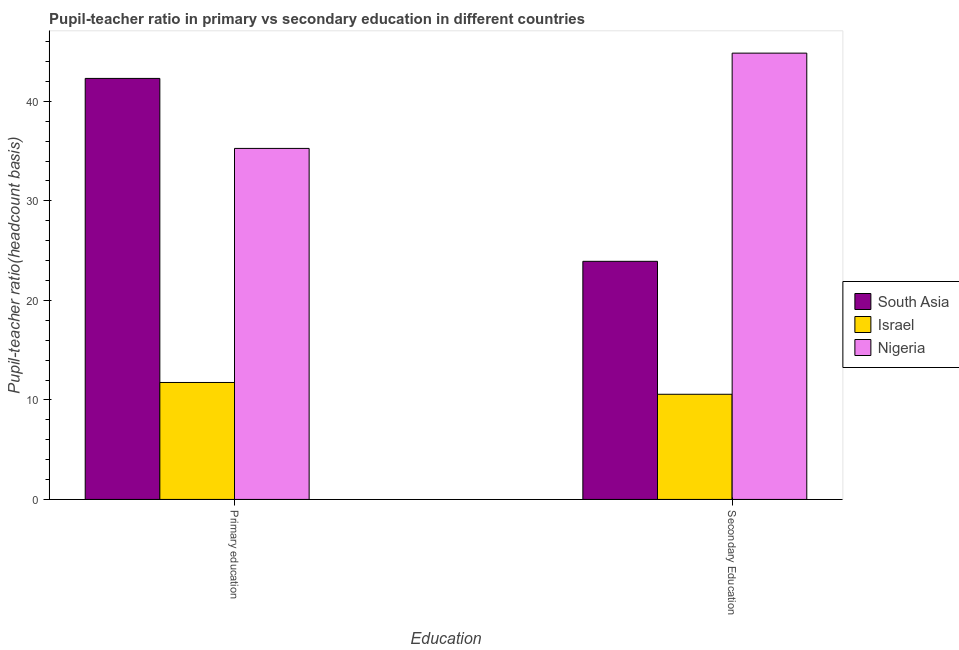How many different coloured bars are there?
Give a very brief answer. 3. Are the number of bars per tick equal to the number of legend labels?
Offer a very short reply. Yes. Are the number of bars on each tick of the X-axis equal?
Provide a succinct answer. Yes. How many bars are there on the 2nd tick from the left?
Your response must be concise. 3. What is the pupil teacher ratio on secondary education in Israel?
Ensure brevity in your answer.  10.57. Across all countries, what is the maximum pupil-teacher ratio in primary education?
Make the answer very short. 42.31. Across all countries, what is the minimum pupil-teacher ratio in primary education?
Your answer should be compact. 11.75. In which country was the pupil-teacher ratio in primary education maximum?
Your response must be concise. South Asia. What is the total pupil-teacher ratio in primary education in the graph?
Ensure brevity in your answer.  89.33. What is the difference between the pupil-teacher ratio in primary education in Israel and that in Nigeria?
Your answer should be compact. -23.52. What is the difference between the pupil teacher ratio on secondary education in Israel and the pupil-teacher ratio in primary education in Nigeria?
Offer a terse response. -24.7. What is the average pupil teacher ratio on secondary education per country?
Your answer should be very brief. 26.45. What is the difference between the pupil teacher ratio on secondary education and pupil-teacher ratio in primary education in South Asia?
Give a very brief answer. -18.38. What is the ratio of the pupil teacher ratio on secondary education in Nigeria to that in Israel?
Make the answer very short. 4.24. What does the 2nd bar from the left in Primary education represents?
Your answer should be very brief. Israel. What does the 3rd bar from the right in Primary education represents?
Offer a terse response. South Asia. How many countries are there in the graph?
Provide a succinct answer. 3. Are the values on the major ticks of Y-axis written in scientific E-notation?
Your answer should be compact. No. Does the graph contain grids?
Keep it short and to the point. No. How are the legend labels stacked?
Your answer should be compact. Vertical. What is the title of the graph?
Your answer should be compact. Pupil-teacher ratio in primary vs secondary education in different countries. Does "Peru" appear as one of the legend labels in the graph?
Make the answer very short. No. What is the label or title of the X-axis?
Ensure brevity in your answer.  Education. What is the label or title of the Y-axis?
Offer a terse response. Pupil-teacher ratio(headcount basis). What is the Pupil-teacher ratio(headcount basis) in South Asia in Primary education?
Your answer should be compact. 42.31. What is the Pupil-teacher ratio(headcount basis) of Israel in Primary education?
Provide a succinct answer. 11.75. What is the Pupil-teacher ratio(headcount basis) in Nigeria in Primary education?
Your response must be concise. 35.27. What is the Pupil-teacher ratio(headcount basis) of South Asia in Secondary Education?
Provide a succinct answer. 23.93. What is the Pupil-teacher ratio(headcount basis) of Israel in Secondary Education?
Ensure brevity in your answer.  10.57. What is the Pupil-teacher ratio(headcount basis) in Nigeria in Secondary Education?
Make the answer very short. 44.85. Across all Education, what is the maximum Pupil-teacher ratio(headcount basis) in South Asia?
Ensure brevity in your answer.  42.31. Across all Education, what is the maximum Pupil-teacher ratio(headcount basis) of Israel?
Your response must be concise. 11.75. Across all Education, what is the maximum Pupil-teacher ratio(headcount basis) in Nigeria?
Keep it short and to the point. 44.85. Across all Education, what is the minimum Pupil-teacher ratio(headcount basis) of South Asia?
Give a very brief answer. 23.93. Across all Education, what is the minimum Pupil-teacher ratio(headcount basis) in Israel?
Your answer should be very brief. 10.57. Across all Education, what is the minimum Pupil-teacher ratio(headcount basis) of Nigeria?
Ensure brevity in your answer.  35.27. What is the total Pupil-teacher ratio(headcount basis) in South Asia in the graph?
Offer a terse response. 66.23. What is the total Pupil-teacher ratio(headcount basis) in Israel in the graph?
Ensure brevity in your answer.  22.32. What is the total Pupil-teacher ratio(headcount basis) in Nigeria in the graph?
Give a very brief answer. 80.12. What is the difference between the Pupil-teacher ratio(headcount basis) in South Asia in Primary education and that in Secondary Education?
Provide a succinct answer. 18.38. What is the difference between the Pupil-teacher ratio(headcount basis) of Israel in Primary education and that in Secondary Education?
Provide a short and direct response. 1.19. What is the difference between the Pupil-teacher ratio(headcount basis) in Nigeria in Primary education and that in Secondary Education?
Offer a very short reply. -9.57. What is the difference between the Pupil-teacher ratio(headcount basis) of South Asia in Primary education and the Pupil-teacher ratio(headcount basis) of Israel in Secondary Education?
Give a very brief answer. 31.74. What is the difference between the Pupil-teacher ratio(headcount basis) in South Asia in Primary education and the Pupil-teacher ratio(headcount basis) in Nigeria in Secondary Education?
Make the answer very short. -2.54. What is the difference between the Pupil-teacher ratio(headcount basis) of Israel in Primary education and the Pupil-teacher ratio(headcount basis) of Nigeria in Secondary Education?
Your answer should be compact. -33.09. What is the average Pupil-teacher ratio(headcount basis) of South Asia per Education?
Offer a very short reply. 33.12. What is the average Pupil-teacher ratio(headcount basis) in Israel per Education?
Your response must be concise. 11.16. What is the average Pupil-teacher ratio(headcount basis) of Nigeria per Education?
Your answer should be compact. 40.06. What is the difference between the Pupil-teacher ratio(headcount basis) of South Asia and Pupil-teacher ratio(headcount basis) of Israel in Primary education?
Offer a terse response. 30.55. What is the difference between the Pupil-teacher ratio(headcount basis) of South Asia and Pupil-teacher ratio(headcount basis) of Nigeria in Primary education?
Your answer should be very brief. 7.03. What is the difference between the Pupil-teacher ratio(headcount basis) of Israel and Pupil-teacher ratio(headcount basis) of Nigeria in Primary education?
Offer a very short reply. -23.52. What is the difference between the Pupil-teacher ratio(headcount basis) of South Asia and Pupil-teacher ratio(headcount basis) of Israel in Secondary Education?
Your answer should be very brief. 13.36. What is the difference between the Pupil-teacher ratio(headcount basis) in South Asia and Pupil-teacher ratio(headcount basis) in Nigeria in Secondary Education?
Provide a short and direct response. -20.92. What is the difference between the Pupil-teacher ratio(headcount basis) in Israel and Pupil-teacher ratio(headcount basis) in Nigeria in Secondary Education?
Offer a very short reply. -34.28. What is the ratio of the Pupil-teacher ratio(headcount basis) in South Asia in Primary education to that in Secondary Education?
Keep it short and to the point. 1.77. What is the ratio of the Pupil-teacher ratio(headcount basis) of Israel in Primary education to that in Secondary Education?
Offer a terse response. 1.11. What is the ratio of the Pupil-teacher ratio(headcount basis) of Nigeria in Primary education to that in Secondary Education?
Your answer should be very brief. 0.79. What is the difference between the highest and the second highest Pupil-teacher ratio(headcount basis) of South Asia?
Offer a terse response. 18.38. What is the difference between the highest and the second highest Pupil-teacher ratio(headcount basis) of Israel?
Keep it short and to the point. 1.19. What is the difference between the highest and the second highest Pupil-teacher ratio(headcount basis) of Nigeria?
Ensure brevity in your answer.  9.57. What is the difference between the highest and the lowest Pupil-teacher ratio(headcount basis) in South Asia?
Your answer should be very brief. 18.38. What is the difference between the highest and the lowest Pupil-teacher ratio(headcount basis) in Israel?
Provide a short and direct response. 1.19. What is the difference between the highest and the lowest Pupil-teacher ratio(headcount basis) in Nigeria?
Ensure brevity in your answer.  9.57. 